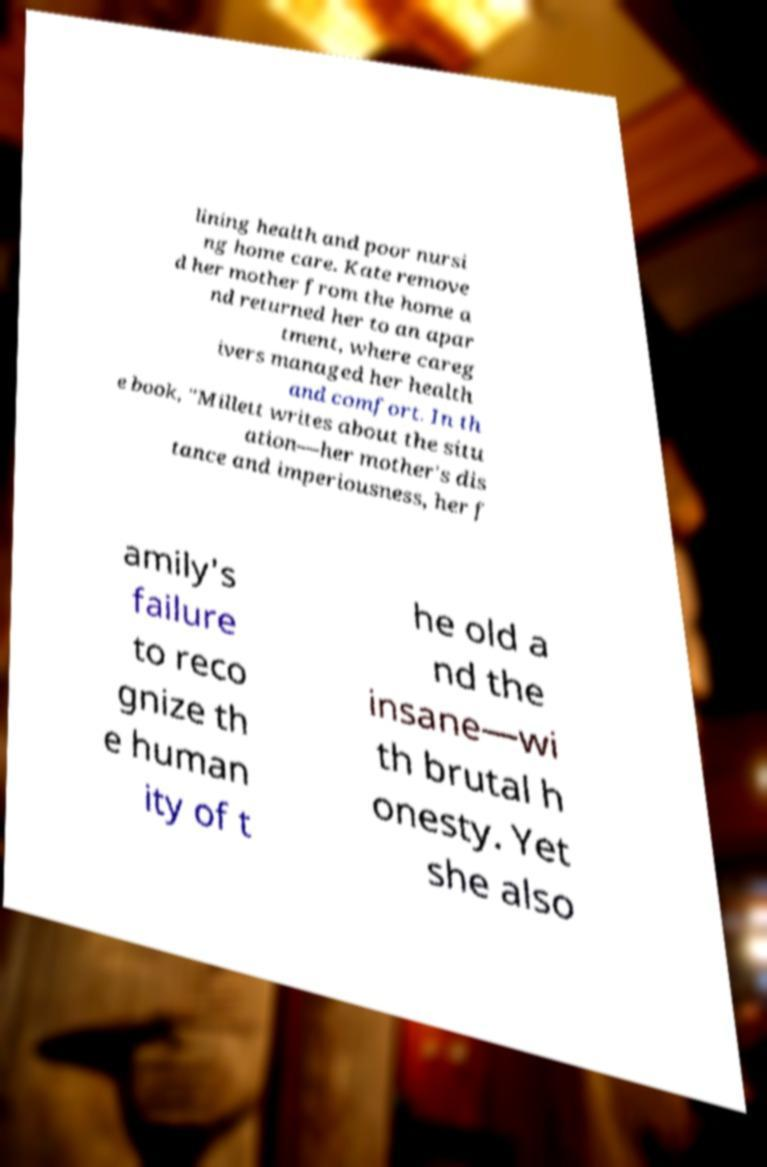Can you read and provide the text displayed in the image?This photo seems to have some interesting text. Can you extract and type it out for me? lining health and poor nursi ng home care. Kate remove d her mother from the home a nd returned her to an apar tment, where careg ivers managed her health and comfort. In th e book, "Millett writes about the situ ation—her mother's dis tance and imperiousness, her f amily's failure to reco gnize th e human ity of t he old a nd the insane—wi th brutal h onesty. Yet she also 